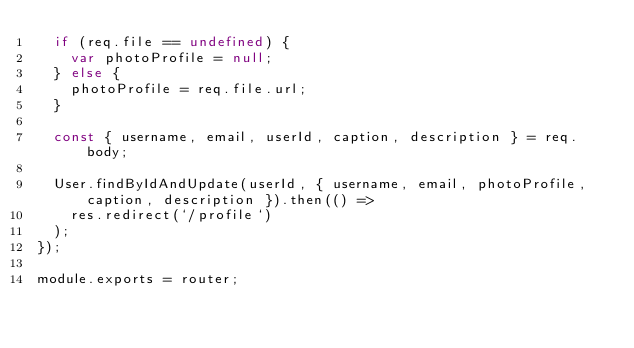<code> <loc_0><loc_0><loc_500><loc_500><_JavaScript_>  if (req.file == undefined) {
    var photoProfile = null;
  } else {
    photoProfile = req.file.url;
  }

  const { username, email, userId, caption, description } = req.body;

  User.findByIdAndUpdate(userId, { username, email, photoProfile, caption, description }).then(() =>
    res.redirect(`/profile`)
  );
});

module.exports = router;
</code> 